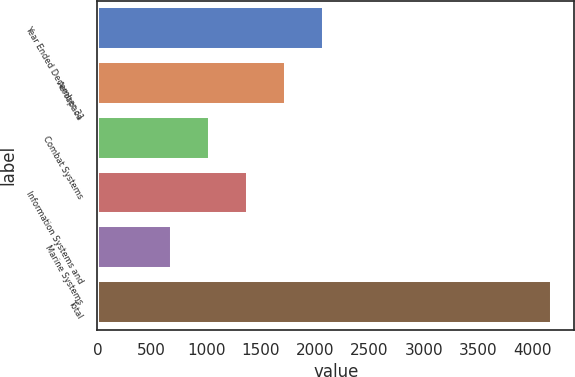Convert chart to OTSL. <chart><loc_0><loc_0><loc_500><loc_500><bar_chart><fcel>Year Ended December 31<fcel>Aerospace<fcel>Combat Systems<fcel>Information Systems and<fcel>Marine Systems<fcel>Total<nl><fcel>2081.8<fcel>1732.6<fcel>1034.2<fcel>1383.4<fcel>685<fcel>4177<nl></chart> 